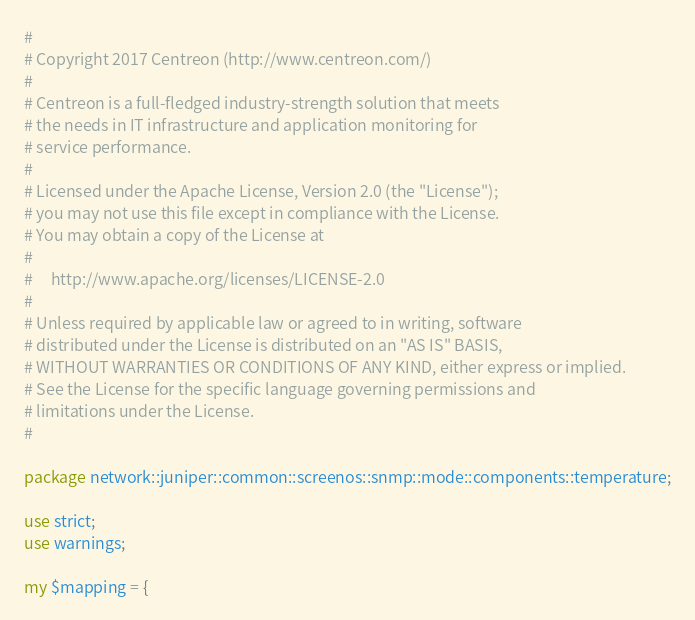Convert code to text. <code><loc_0><loc_0><loc_500><loc_500><_Perl_>#
# Copyright 2017 Centreon (http://www.centreon.com/)
#
# Centreon is a full-fledged industry-strength solution that meets
# the needs in IT infrastructure and application monitoring for
# service performance.
#
# Licensed under the Apache License, Version 2.0 (the "License");
# you may not use this file except in compliance with the License.
# You may obtain a copy of the License at
#
#     http://www.apache.org/licenses/LICENSE-2.0
#
# Unless required by applicable law or agreed to in writing, software
# distributed under the License is distributed on an "AS IS" BASIS,
# WITHOUT WARRANTIES OR CONDITIONS OF ANY KIND, either express or implied.
# See the License for the specific language governing permissions and
# limitations under the License.
#

package network::juniper::common::screenos::snmp::mode::components::temperature;

use strict;
use warnings;

my $mapping = {</code> 